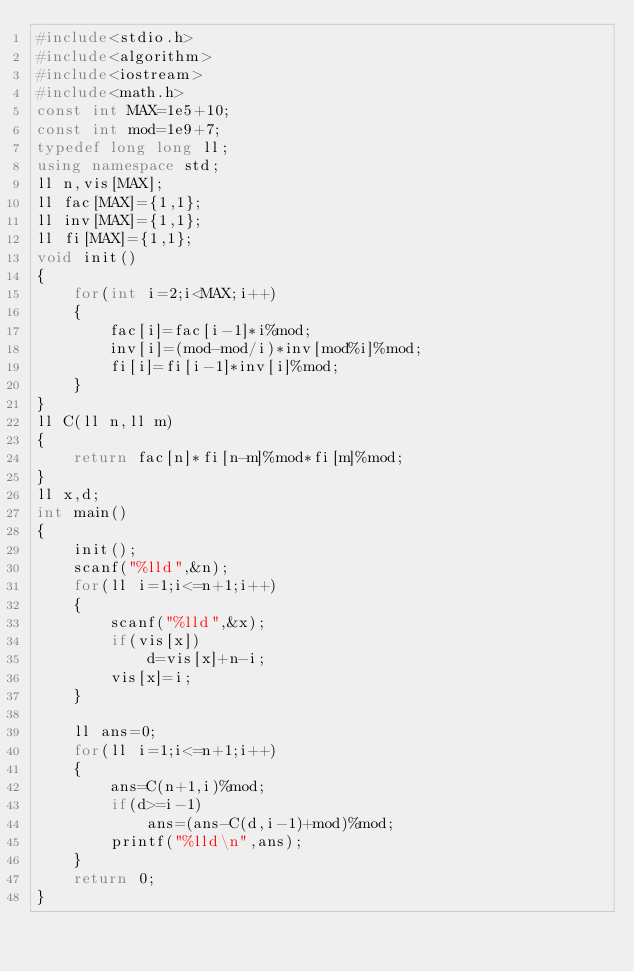<code> <loc_0><loc_0><loc_500><loc_500><_C++_>#include<stdio.h>
#include<algorithm>
#include<iostream>
#include<math.h>
const int MAX=1e5+10;
const int mod=1e9+7;
typedef long long ll;
using namespace std;
ll n,vis[MAX];
ll fac[MAX]={1,1};
ll inv[MAX]={1,1};
ll fi[MAX]={1,1};
void init()
{
    for(int i=2;i<MAX;i++)
    {
        fac[i]=fac[i-1]*i%mod;
        inv[i]=(mod-mod/i)*inv[mod%i]%mod;
        fi[i]=fi[i-1]*inv[i]%mod;
    }
}
ll C(ll n,ll m)
{
    return fac[n]*fi[n-m]%mod*fi[m]%mod;
}
ll x,d;
int main()
{
    init();
    scanf("%lld",&n);
    for(ll i=1;i<=n+1;i++)
    {
        scanf("%lld",&x);
        if(vis[x])
            d=vis[x]+n-i;
        vis[x]=i;
    }

    ll ans=0;
    for(ll i=1;i<=n+1;i++)
    {
        ans=C(n+1,i)%mod;
        if(d>=i-1)
            ans=(ans-C(d,i-1)+mod)%mod;
        printf("%lld\n",ans);
    }
    return 0;
}

</code> 